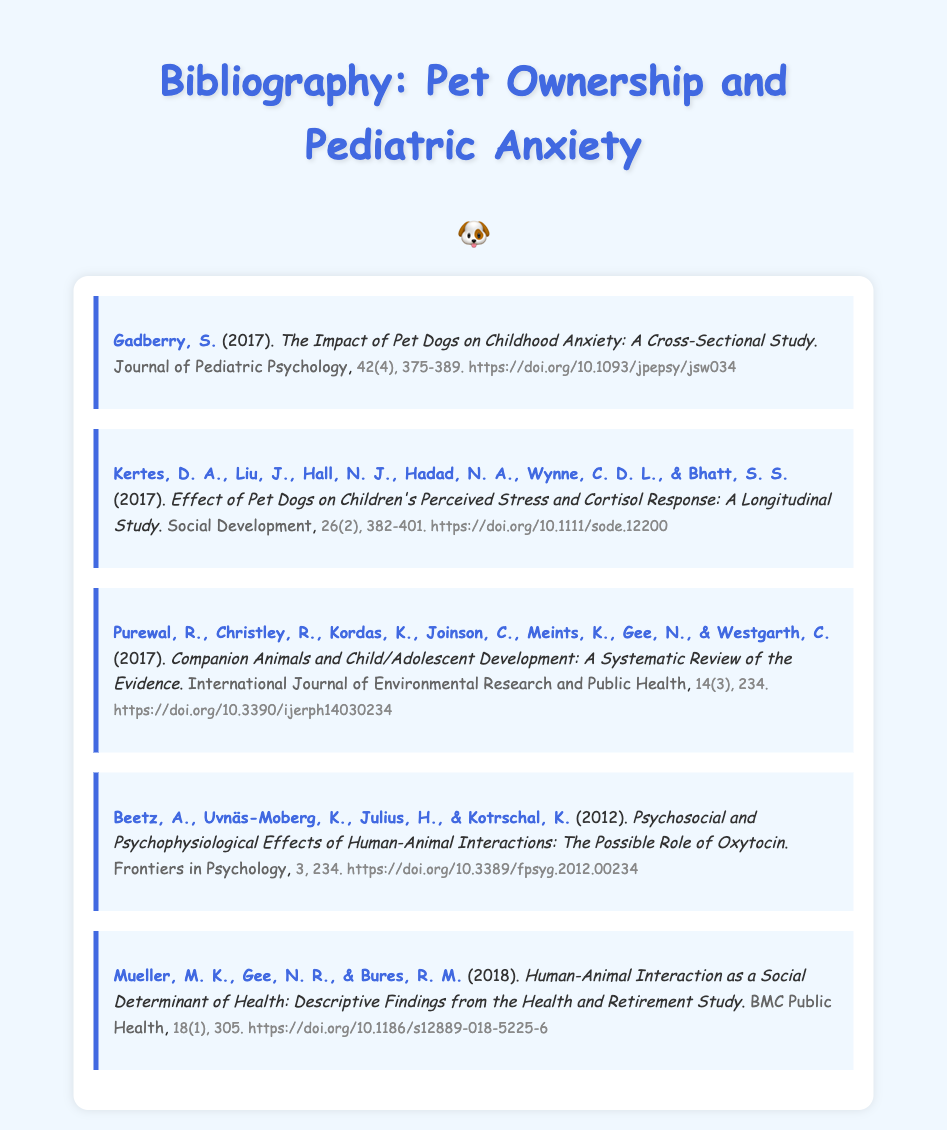What is the title of the first entry? The title of the first entry is found in the citation format, specifically following the author's name and year.
Answer: The Impact of Pet Dogs on Childhood Anxiety: A Cross-Sectional Study Who are the authors of the second entry? The authors are listed directly after the title, providing full names of the researchers involved in the study.
Answer: Kertes, D. A., Liu, J., Hall, N. J., Hadad, N. A., Wynne, C. D. L., & Bhatt, S. S What year was the fourth study published? The publication year is indicated in parentheses after the author's names at the beginning of each entry.
Answer: 2012 Which journal published the third entry? The journal name appears after the title of the entry, indicating where the study was published.
Answer: International Journal of Environmental Research and Public Health What is the volume and page range of the second entry? The volume and page numbers are provided in the details section at the end of each entry indicating the specific publication information.
Answer: 26(2), 382-401 How many entries are there in this bibliography? The total number of entries can be counted by reviewing the list provided in the bibliography section of the document.
Answer: 5 What common theme is explored in this bibliography? The entries collectively focus on the relationship between pet ownership and its effects on children, particularly relating to anxiety.
Answer: Pediatric anxiety reduction What effect does pet ownership seem to have, according to the studies? The studies examine the impact of pets on children's stress and anxiety levels, suggesting a beneficial effect.
Answer: Anxiety reduction 